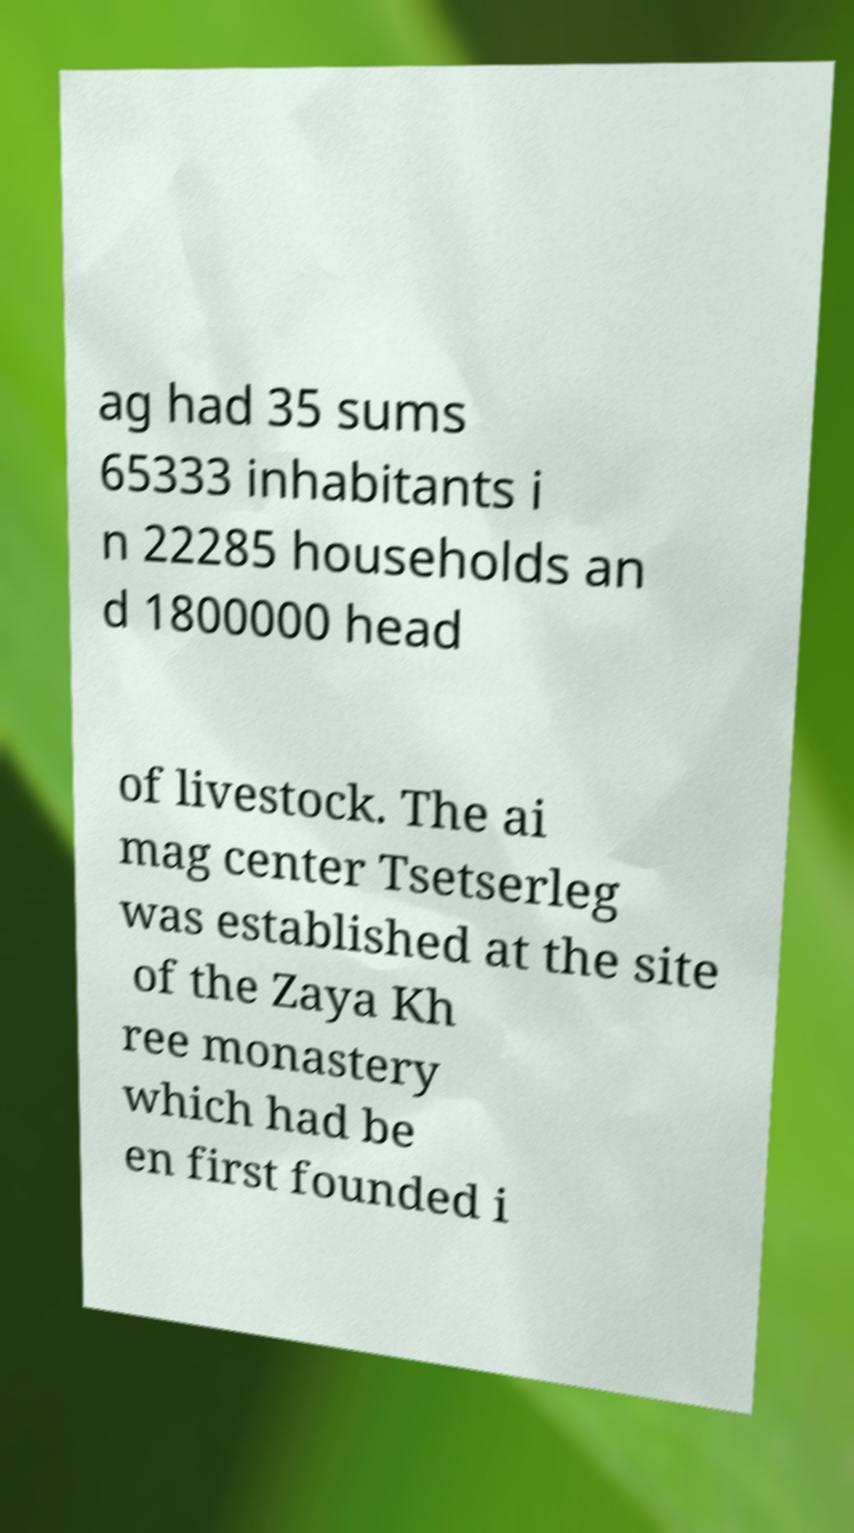Please read and relay the text visible in this image. What does it say? ag had 35 sums 65333 inhabitants i n 22285 households an d 1800000 head of livestock. The ai mag center Tsetserleg was established at the site of the Zaya Kh ree monastery which had be en first founded i 